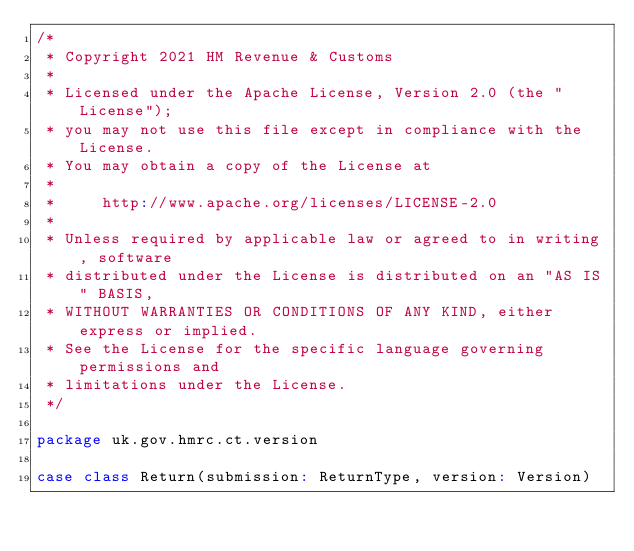<code> <loc_0><loc_0><loc_500><loc_500><_Scala_>/*
 * Copyright 2021 HM Revenue & Customs
 *
 * Licensed under the Apache License, Version 2.0 (the "License");
 * you may not use this file except in compliance with the License.
 * You may obtain a copy of the License at
 *
 *     http://www.apache.org/licenses/LICENSE-2.0
 *
 * Unless required by applicable law or agreed to in writing, software
 * distributed under the License is distributed on an "AS IS" BASIS,
 * WITHOUT WARRANTIES OR CONDITIONS OF ANY KIND, either express or implied.
 * See the License for the specific language governing permissions and
 * limitations under the License.
 */

package uk.gov.hmrc.ct.version

case class Return(submission: ReturnType, version: Version)
</code> 